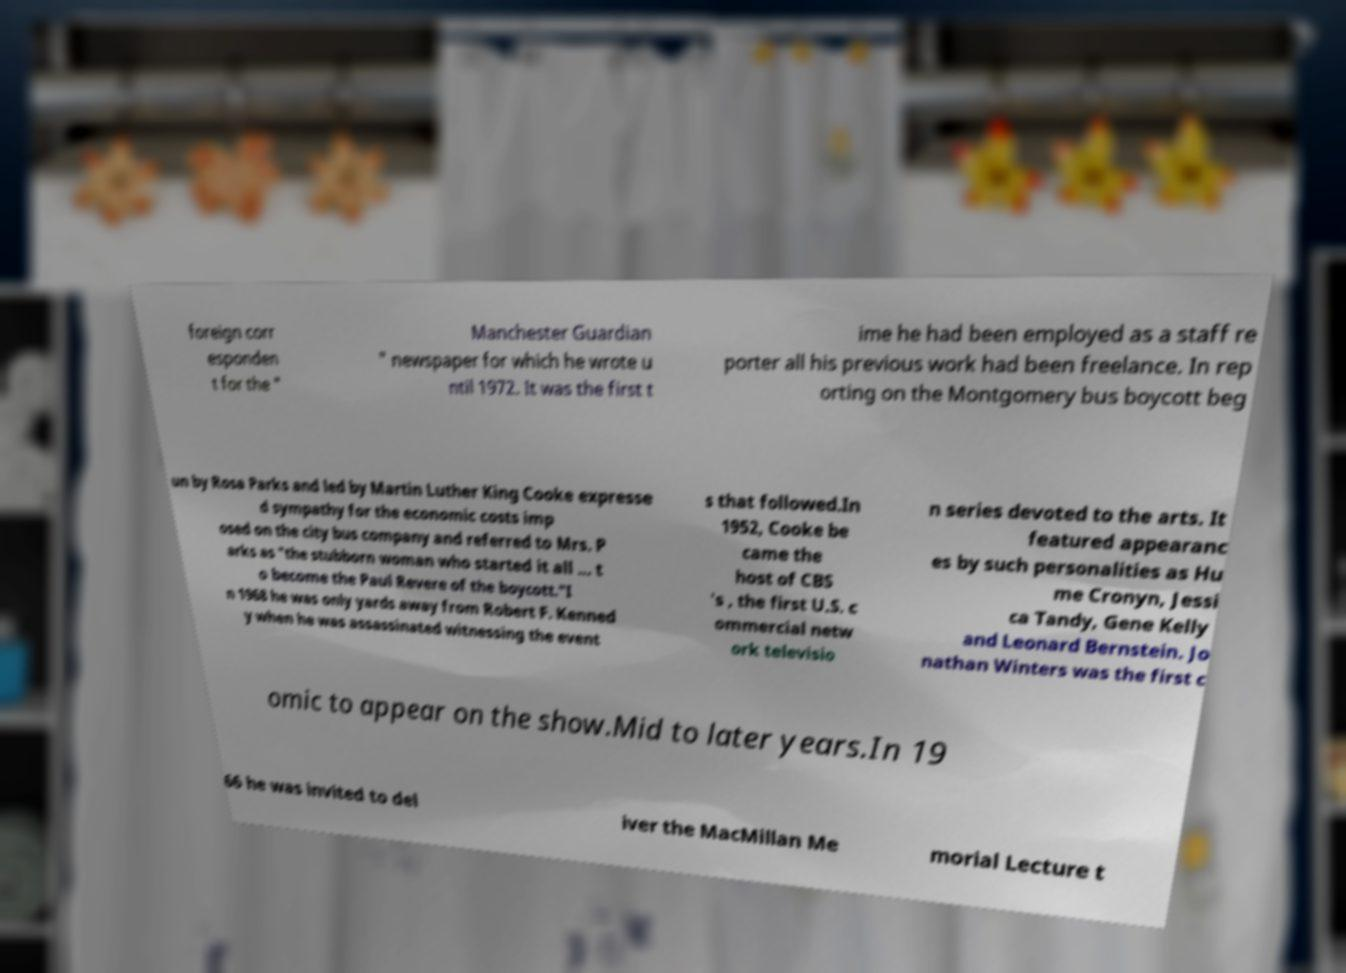Please read and relay the text visible in this image. What does it say? foreign corr esponden t for the " Manchester Guardian " newspaper for which he wrote u ntil 1972. It was the first t ime he had been employed as a staff re porter all his previous work had been freelance. In rep orting on the Montgomery bus boycott beg un by Rosa Parks and led by Martin Luther King Cooke expresse d sympathy for the economic costs imp osed on the city bus company and referred to Mrs. P arks as "the stubborn woman who started it all ... t o become the Paul Revere of the boycott."I n 1968 he was only yards away from Robert F. Kenned y when he was assassinated witnessing the event s that followed.In 1952, Cooke be came the host of CBS 's , the first U.S. c ommercial netw ork televisio n series devoted to the arts. It featured appearanc es by such personalities as Hu me Cronyn, Jessi ca Tandy, Gene Kelly and Leonard Bernstein. Jo nathan Winters was the first c omic to appear on the show.Mid to later years.In 19 66 he was invited to del iver the MacMillan Me morial Lecture t 